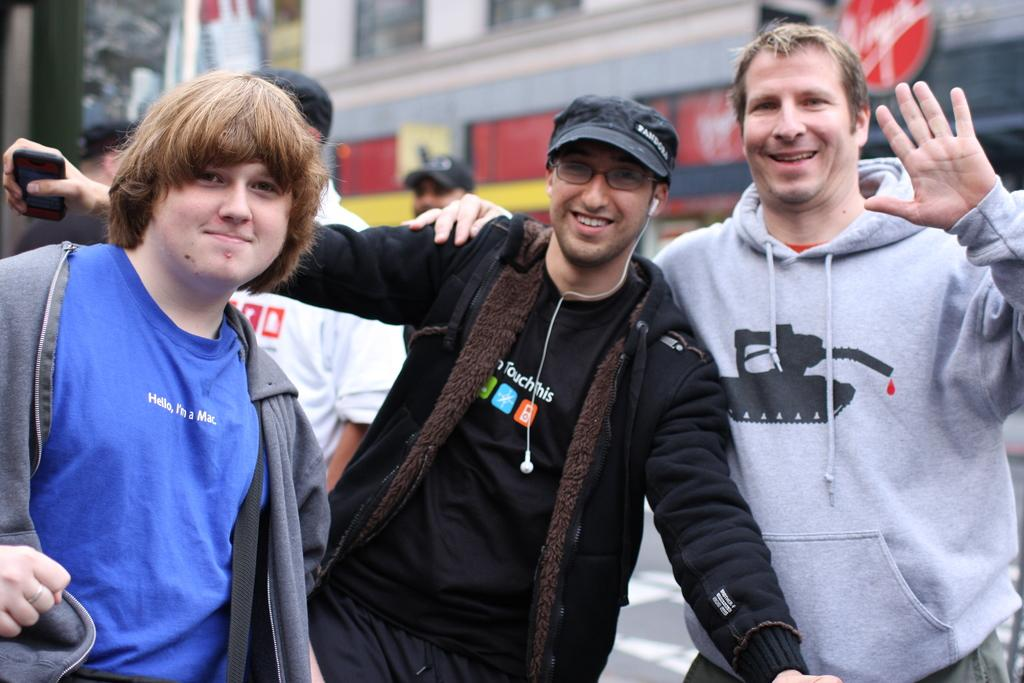How many people are present in the image? There are three persons standing in the image. What is the facial expression of the persons in the image? The persons are smiling. What can be seen in the background of the image? There is a building in the background of the image. Are there any other people visible in the image? Yes, there are three additional persons in the background of the image. How many quarters are being used to pay for the trip in the image? There is no indication of a trip or payment in the image, and quarters are not mentioned or visible. 